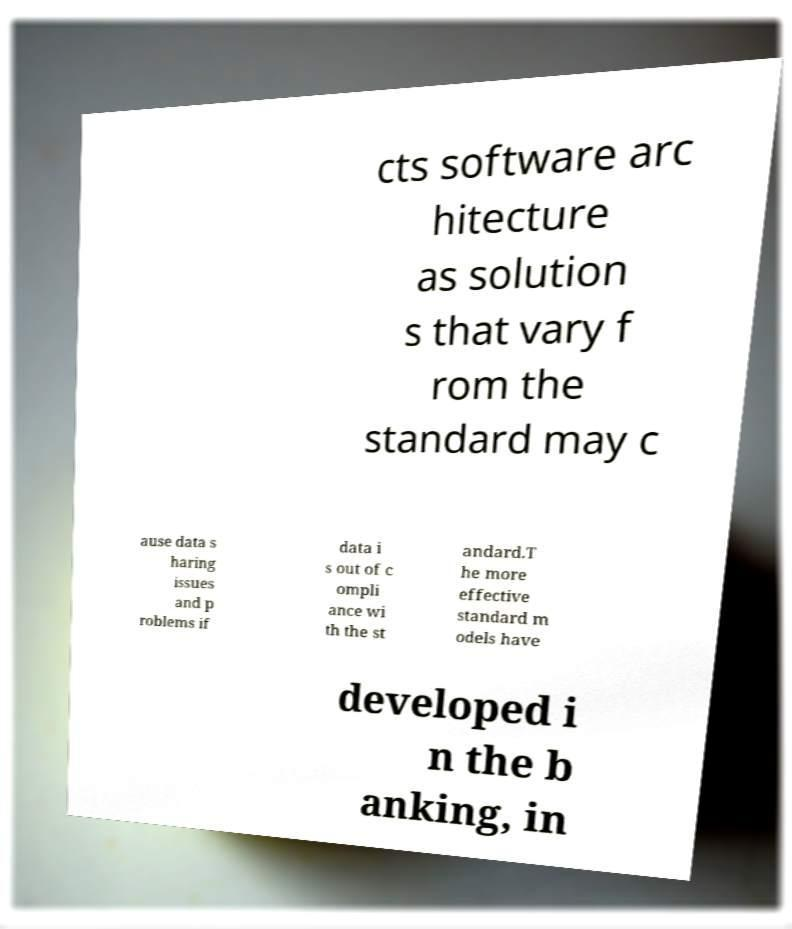Please identify and transcribe the text found in this image. cts software arc hitecture as solution s that vary f rom the standard may c ause data s haring issues and p roblems if data i s out of c ompli ance wi th the st andard.T he more effective standard m odels have developed i n the b anking, in 